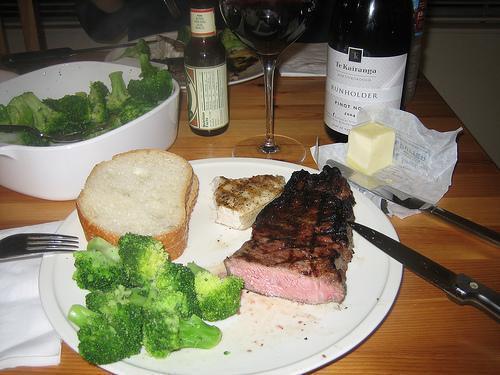How many glass bottles are on the table?
Give a very brief answer. 2. 